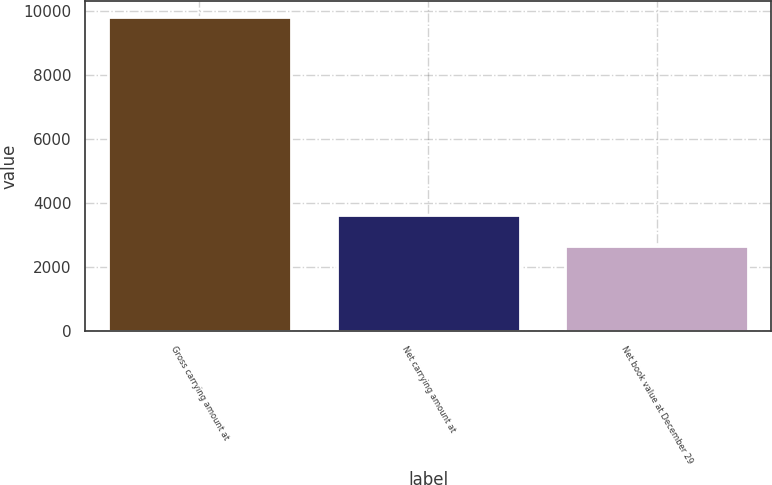Convert chart. <chart><loc_0><loc_0><loc_500><loc_500><bar_chart><fcel>Gross carrying amount at<fcel>Net carrying amount at<fcel>Net book value at December 29<nl><fcel>9800<fcel>3618<fcel>2658<nl></chart> 